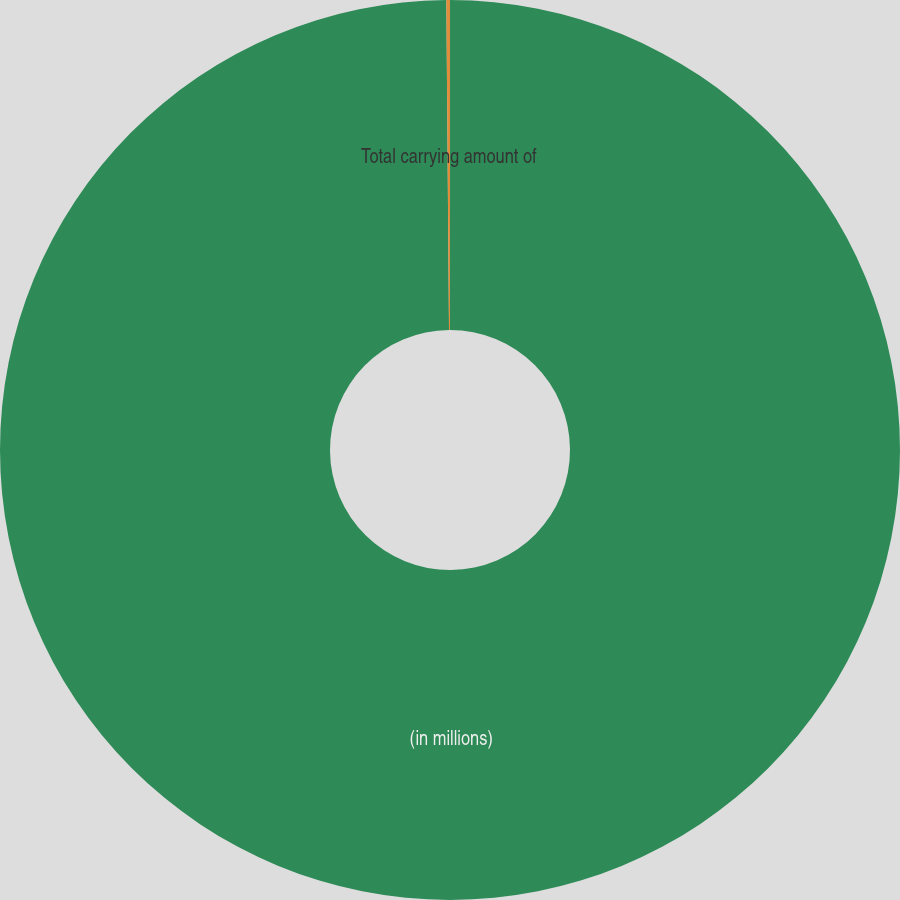Convert chart to OTSL. <chart><loc_0><loc_0><loc_500><loc_500><pie_chart><fcel>(in millions)<fcel>Total carrying amount of<nl><fcel>99.87%<fcel>0.13%<nl></chart> 